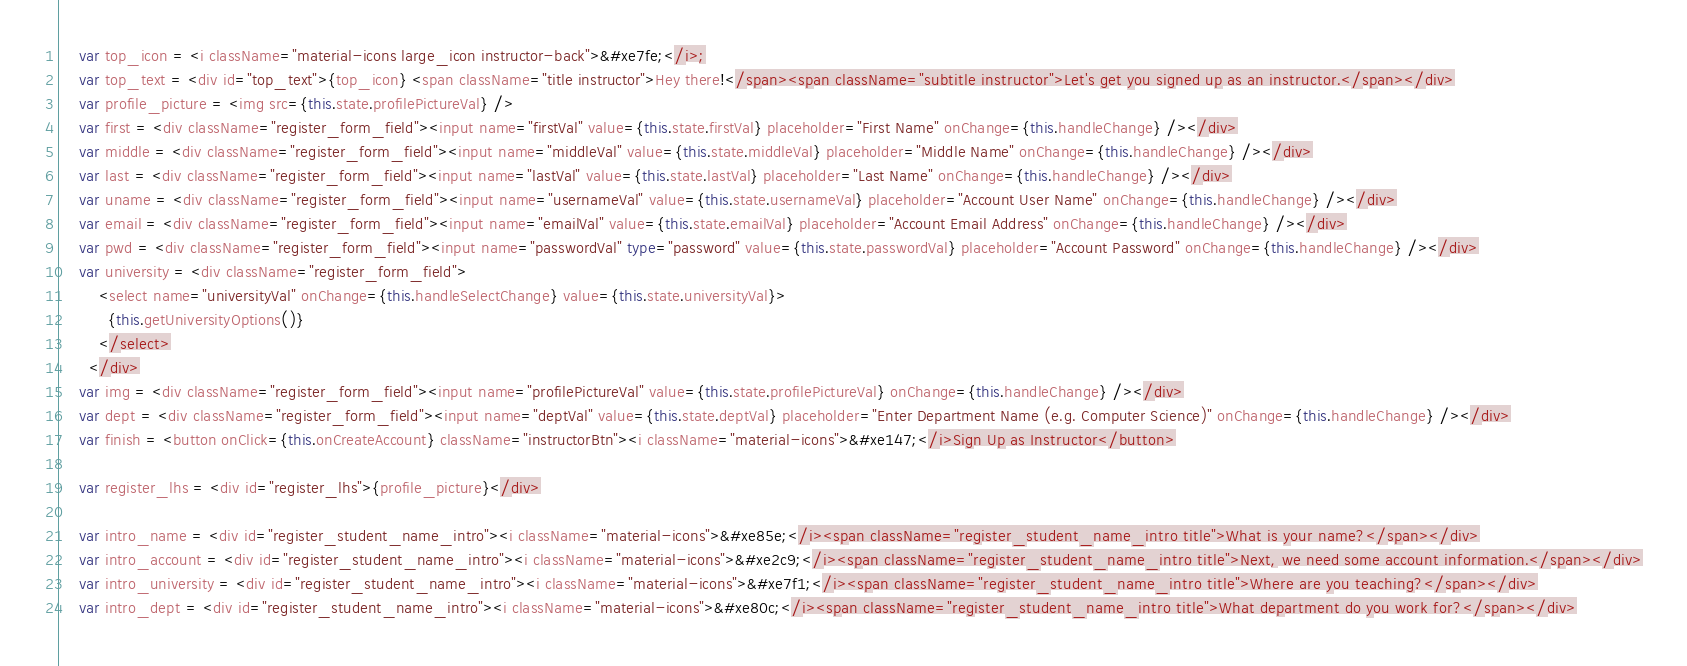<code> <loc_0><loc_0><loc_500><loc_500><_TypeScript_>    var top_icon = <i className="material-icons large_icon instructor-back">&#xe7fe;</i>;
    var top_text = <div id="top_text">{top_icon} <span className="title instructor">Hey there!</span><span className="subtitle instructor">Let's get you signed up as an instructor.</span></div>
    var profile_picture = <img src={this.state.profilePictureVal} />
    var first = <div className="register_form_field"><input name="firstVal" value={this.state.firstVal} placeholder="First Name" onChange={this.handleChange} /></div>
    var middle = <div className="register_form_field"><input name="middleVal" value={this.state.middleVal} placeholder="Middle Name" onChange={this.handleChange} /></div>
    var last = <div className="register_form_field"><input name="lastVal" value={this.state.lastVal} placeholder="Last Name" onChange={this.handleChange} /></div>
    var uname = <div className="register_form_field"><input name="usernameVal" value={this.state.usernameVal} placeholder="Account User Name" onChange={this.handleChange} /></div>
    var email = <div className="register_form_field"><input name="emailVal" value={this.state.emailVal} placeholder="Account Email Address" onChange={this.handleChange} /></div>
    var pwd = <div className="register_form_field"><input name="passwordVal" type="password" value={this.state.passwordVal} placeholder="Account Password" onChange={this.handleChange} /></div>
    var university = <div className="register_form_field">
        <select name="universityVal" onChange={this.handleSelectChange} value={this.state.universityVal}>
          {this.getUniversityOptions()}
        </select>
      </div>
    var img = <div className="register_form_field"><input name="profilePictureVal" value={this.state.profilePictureVal} onChange={this.handleChange} /></div>
    var dept = <div className="register_form_field"><input name="deptVal" value={this.state.deptVal} placeholder="Enter Department Name (e.g. Computer Science)" onChange={this.handleChange} /></div>
    var finish = <button onClick={this.onCreateAccount} className="instructorBtn"><i className="material-icons">&#xe147;</i>Sign Up as Instructor</button>

    var register_lhs = <div id="register_lhs">{profile_picture}</div>

    var intro_name = <div id="register_student_name_intro"><i className="material-icons">&#xe85e;</i><span className="register_student_name_intro title">What is your name?</span></div>
    var intro_account = <div id="register_student_name_intro"><i className="material-icons">&#xe2c9;</i><span className="register_student_name_intro title">Next, we need some account information.</span></div>
    var intro_university = <div id="register_student_name_intro"><i className="material-icons">&#xe7f1;</i><span className="register_student_name_intro title">Where are you teaching?</span></div>
    var intro_dept = <div id="register_student_name_intro"><i className="material-icons">&#xe80c;</i><span className="register_student_name_intro title">What department do you work for?</span></div></code> 